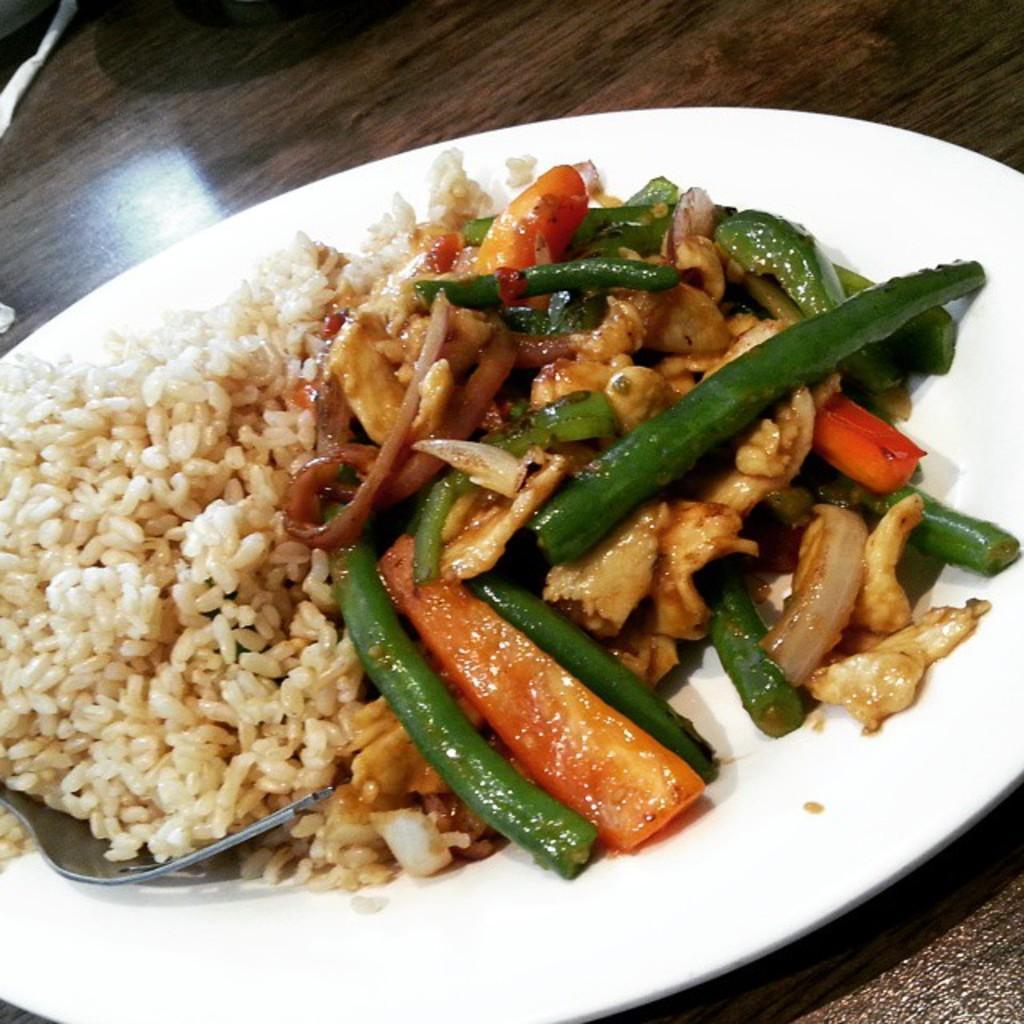How would you summarize this image in a sentence or two? In the picture I can see a dish and a fork on the plate and the plate is kept on the wooden table. 